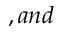Convert formula to latex. <formula><loc_0><loc_0><loc_500><loc_500>, a n d</formula> 